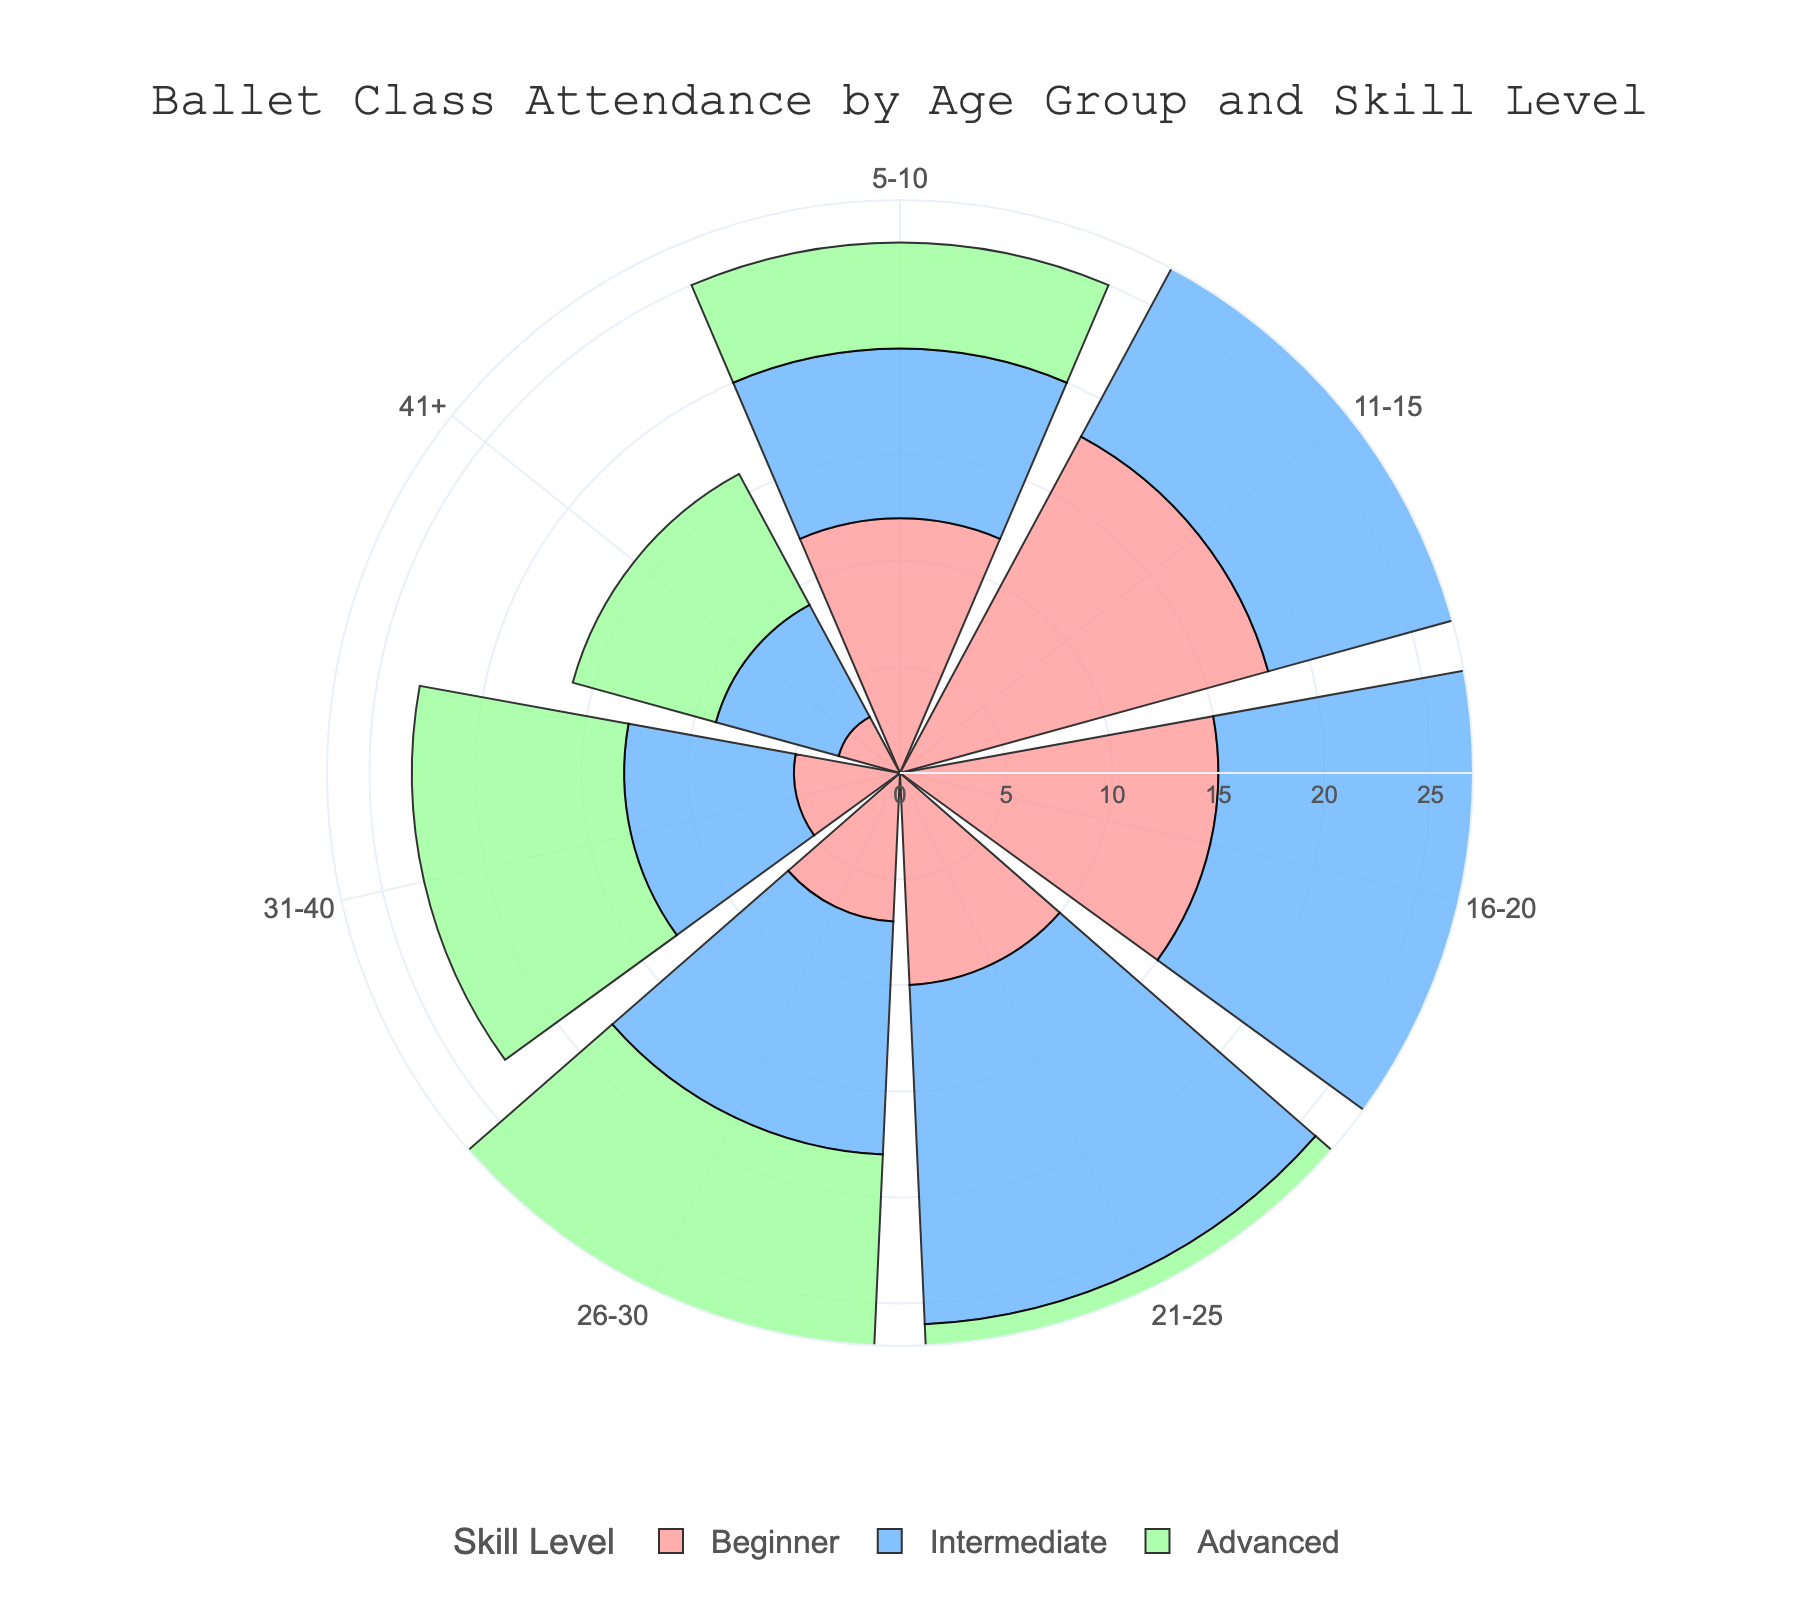What's the title of the figure? The title is displayed at the top center of the figure in a larger font. It reads "Ballet Class Attendance by Age Group and Skill Level".
Answer: Ballet Class Attendance by Age Group and Skill Level How many age groups are represented in the figure? The age groups are represented along the angular axis of the rose chart. Counting them reveals that there are six age groups.
Answer: Six Which age group has the highest number of attendees in the Advanced skill level? In the Advanced skill level, the bar extending the farthest from the center corresponds to the 21-25 age group.
Answer: 21-25 What are the radial values range shown in the figure? The radial axis ranges from 0 to 27, accommodating the maximum number of attendees, which is slightly above 22.
Answer: 0 to 27 How does the attendance of the 11-15 age group compare between Beginner and Intermediate skill levels? The 11-15 age group has 18 attendees in Beginner and 14 in Intermediate. This shows that the Beginner level has more attendees than Intermediate.
Answer: Beginner > Intermediate Which two age groups have the least number of attendees in total? Summing up the attendees for each skill level within age groups, 41+ (total 16) and 31-40 (total 23) are the groups with the least total attendance.
Answer: 41+ and 31-40 What is the total number of attendees in the 5-10 and 21-25 age groups? Summing the attendees: For 5-10: 12 (Beginner) + 8 (Intermediate) + 5 (Advanced) = 25, and for 21-25: 10 (Beginner) + 16 (Intermediate) + 22 (Advanced) = 48.
Answer: 25 and 48 Are there any skill levels where the number of attendees increases as the age group increases? Observing the Advanced skill level across age groups, the number of attendees generally increases with age: 5, 11, 18, 22, 15, 10, 7.
Answer: Yes, Advanced level What color is used to represent the Intermediate skill level, and how does this help differentiate the data? The Intermediate skill level is represented by a blue color, which helps differentiate it from the red (Beginner) and green (Advanced) levels.
Answer: Blue In the 16-20 age group, which skill level has the highest attendance, and by how much? For the 16-20 age group, the Intermediate skill level has 20 attendees, which is the highest. It surpasses the Advanced (18) and Beginner (15) levels.
Answer: Intermediate by 2 